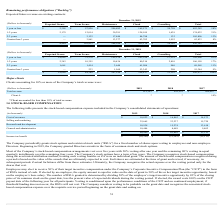From Pegasystems's financial document, What are the company's respective stock-based compensation for  cost of revenues in 2019 and 2018? The document shows two values: $18,822 and $16,862 (in thousands). From the document: "Cost of revenues $ 18,822 $ 16,862 $ 14,573 Cost of revenues $ 18,822 $ 16,862 $ 14,573..." Also, What are the company's respective stock-based compensation for selling and marketing in 2019 and 2018? The document shows two values: 32,665 and 23,237 (in thousands). From the document: "Selling and marketing 32,665 23,237 15,720 Selling and marketing 32,665 23,237 15,720..." Also, What are the company's respective stock-based compensation for research and development in 2019 and 2018? The document shows two values: 18,938 and 15,274 (in thousands). From the document: "Research and development 18,938 15,274 13,618 Research and development 18,938 15,274 13,618..." Also, can you calculate: What is the company's average stock-based compensation for the cost of revenue between 2017 to 2019? To answer this question, I need to perform calculations using the financial data. The calculation is: ($14,573 + $16,862 + $18,822)/3 , which equals 16752.33 (in thousands). This is based on the information: "Cost of revenues $ 18,822 $ 16,862 $ 14,573 Cost of revenues $ 18,822 $ 16,862 $ 14,573 Cost of revenues $ 18,822 $ 16,862 $ 14,573..." The key data points involved are: 14,573, 16,862, 18,822. Also, can you calculate: What is the company's average stock-based compensation for selling and marketing in 2018 and 2019? To answer this question, I need to perform calculations using the financial data. The calculation is: (23,237 + 32,665)/2 , which equals 27951 (in thousands). This is based on the information: "Selling and marketing 32,665 23,237 15,720 Selling and marketing 32,665 23,237 15,720..." The key data points involved are: 23,237, 32,665. Also, can you calculate: What is the company's average stock-based compensation for research and development in 2018 and 2019? To answer this question, I need to perform calculations using the financial data. The calculation is: (18,938 + 15,274)/2, which equals 17106 (in thousands). This is based on the information: "Research and development 18,938 15,274 13,618 Research and development 18,938 15,274 13,618..." The key data points involved are: 15,274, 18,938. 